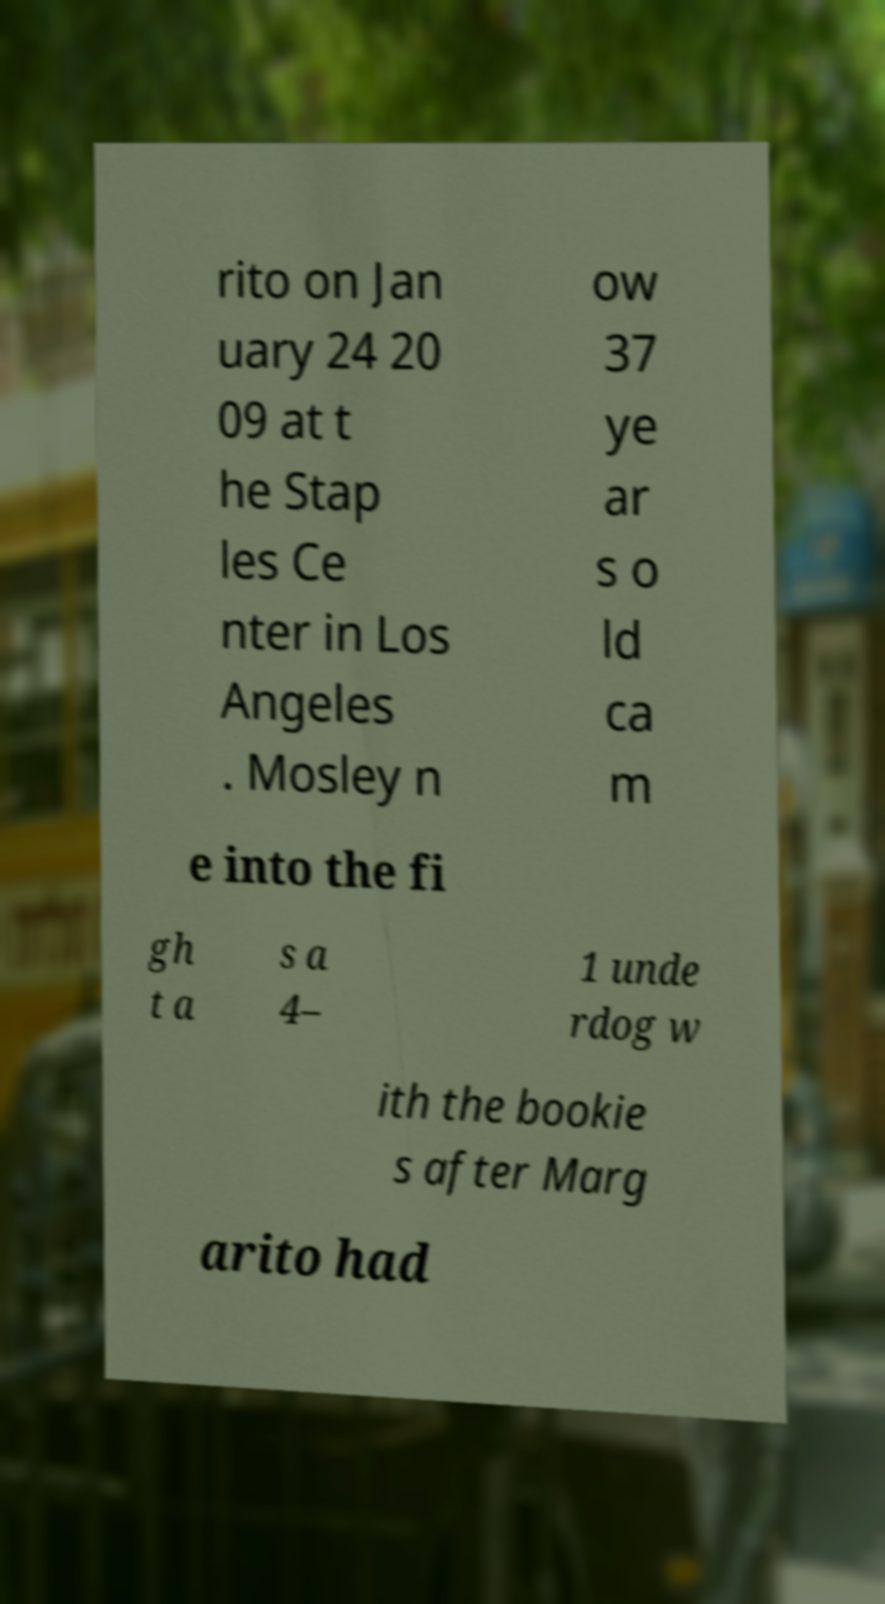I need the written content from this picture converted into text. Can you do that? rito on Jan uary 24 20 09 at t he Stap les Ce nter in Los Angeles . Mosley n ow 37 ye ar s o ld ca m e into the fi gh t a s a 4– 1 unde rdog w ith the bookie s after Marg arito had 